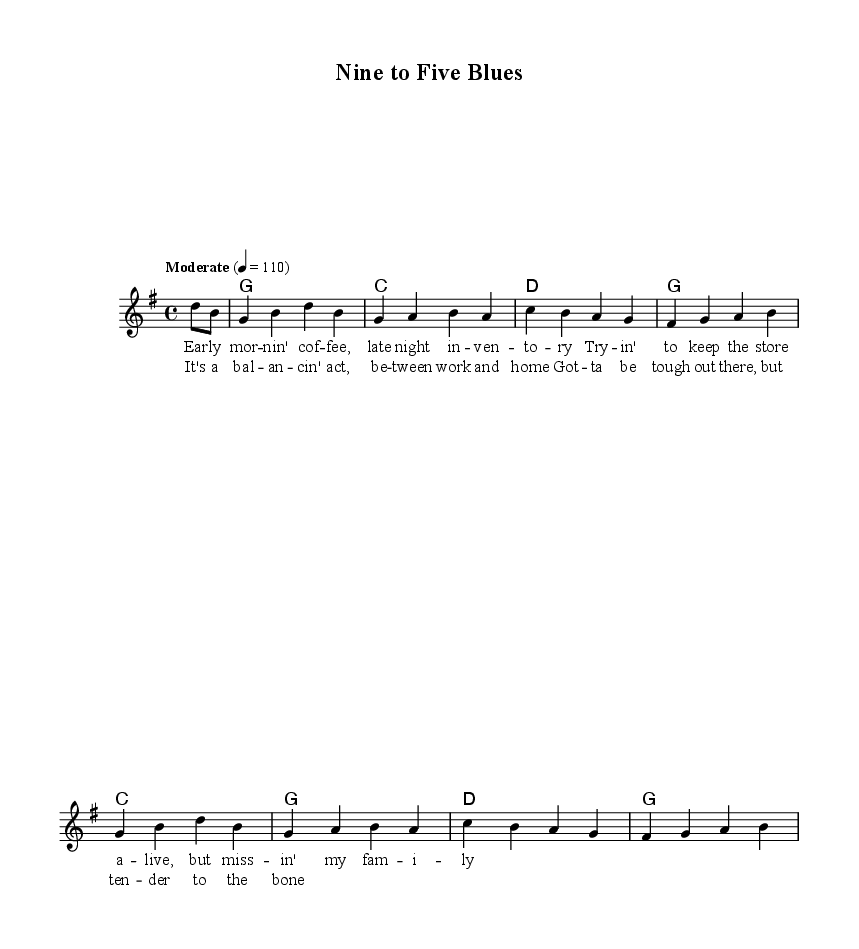What is the key signature of this music? The key signature is G major, which has one sharp (F#).
Answer: G major What is the time signature of this piece? The time signature is 4/4, indicating four beats per measure.
Answer: 4/4 What is the tempo marking given for this song? The tempo marking indicates that the piece should be played at a moderate speed, specifically, at a metronome marking of 110 beats per minute.
Answer: Moderate 4 = 110 How many measures are in the melody section? The melody section has eight measures based on the groupings of notes.
Answer: Eight What is the main theme of the lyrics in this song? The main theme of the lyrics revolves around balancing work and family life, reflecting the challenges faced by someone in a professional setting.
Answer: Balancing work and home Which chord is used at the start of the harmonies? The first chord indicated in the harmonies is G major.
Answer: G How does the chorus relate to the verses in terms of content? The chorus emphasizes the struggle between work and home life, which connects with the narrative of the verses explaining the protagonist's daily experiences.
Answer: The struggle between work and home 